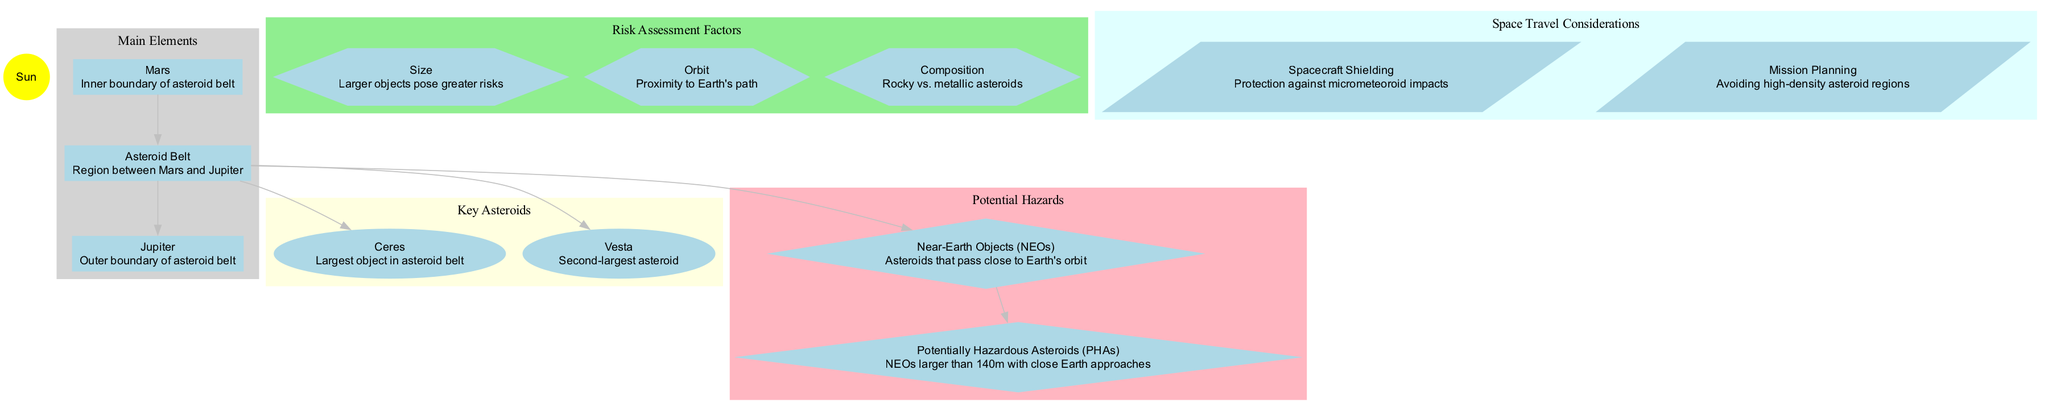What is the inner boundary of the asteroid belt? The diagram shows the planet Mars as the inner boundary of the asteroid belt. It is represented with an edge connecting Mars to the Asteroid Belt.
Answer: Mars What is the largest object in the asteroid belt? According to the diagram, Ceres is indicated as the largest object in the asteroid belt, placed within the key asteroids cluster.
Answer: Ceres How many key asteroids are identified in the diagram? Exploring the key asteroids cluster reveals that there are two nodes listed: Ceres and Vesta. Therefore, the total count is two.
Answer: 2 Which category does "Potentially Hazardous Asteroids" belong to? The "Potentially Hazardous Asteroids" node is connected to the "Near-Earth Objects (NEOs)" node, which indicates it's a subcategory under potential hazards.
Answer: Potential Hazards What is one factor that contributes to risk assessment? The diagram highlights multiple factors, but one specific factor mentioned is "Size," which is displayed in the risk assessment factors section.
Answer: Size Which two planets mark the boundaries of the asteroid belt? The diagram shows that Mars marks the inner boundary, while Jupiter marks the outer boundary, both connected to the asteroid belt.
Answer: Mars and Jupiter What type of shape represents potential hazards in the diagram? The potential hazards nodes, including "NEOs" and "Potentially Hazardous Asteroids (PHAs)," are represented as diamond shapes in the diagram, indicating their specific category.
Answer: Diamond What does "Mission Planning" refer to in space travel considerations? Within the space travel considerations section, "Mission Planning" is described as a vital strategy, particularly aimed at avoiding high-density asteroid regions, emphasizing its practical implications for safe travel.
Answer: Avoiding high-density asteroid regions How does asteroid composition factor into risk assessment? The "Composition" factor in the risk assessment indicators nature distinguishes the types of asteroids, specifically in terms of rocky versus metallic structures, which are critical for evaluating risk potential.
Answer: Rocky vs. metallic asteroids 